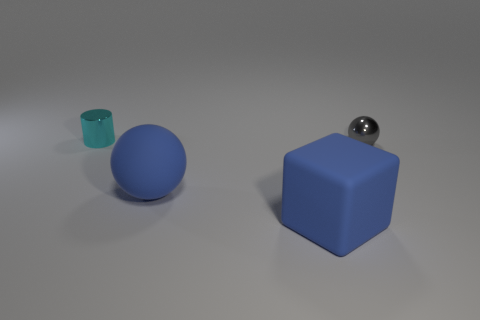What number of tiny metal objects are both on the left side of the big blue cube and in front of the tiny cyan metallic cylinder?
Make the answer very short. 0. Is there any other thing of the same color as the tiny sphere?
Keep it short and to the point. No. What number of matte things are cubes or small cyan things?
Your response must be concise. 1. There is a tiny object that is left of the ball in front of the metallic thing to the right of the metallic cylinder; what is its material?
Your answer should be compact. Metal. There is a small thing behind the small metallic object that is right of the large matte sphere; what is its material?
Provide a succinct answer. Metal. There is a shiny thing that is in front of the tiny cyan cylinder; is its size the same as the metal thing that is behind the gray shiny object?
Ensure brevity in your answer.  Yes. What number of big things are gray metal spheres or brown metal cubes?
Your answer should be compact. 0. What number of objects are metal objects that are left of the large rubber block or gray things?
Give a very brief answer. 2. Is the color of the large sphere the same as the big cube?
Keep it short and to the point. Yes. How many other objects are the same shape as the cyan metal thing?
Make the answer very short. 0. 